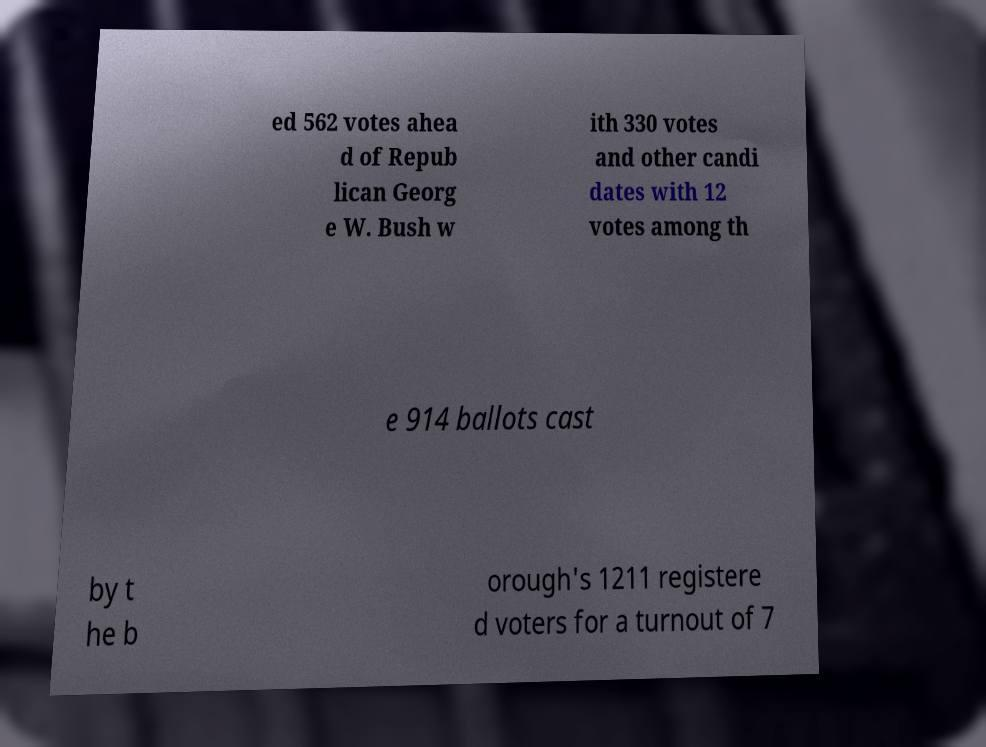Can you accurately transcribe the text from the provided image for me? ed 562 votes ahea d of Repub lican Georg e W. Bush w ith 330 votes and other candi dates with 12 votes among th e 914 ballots cast by t he b orough's 1211 registere d voters for a turnout of 7 